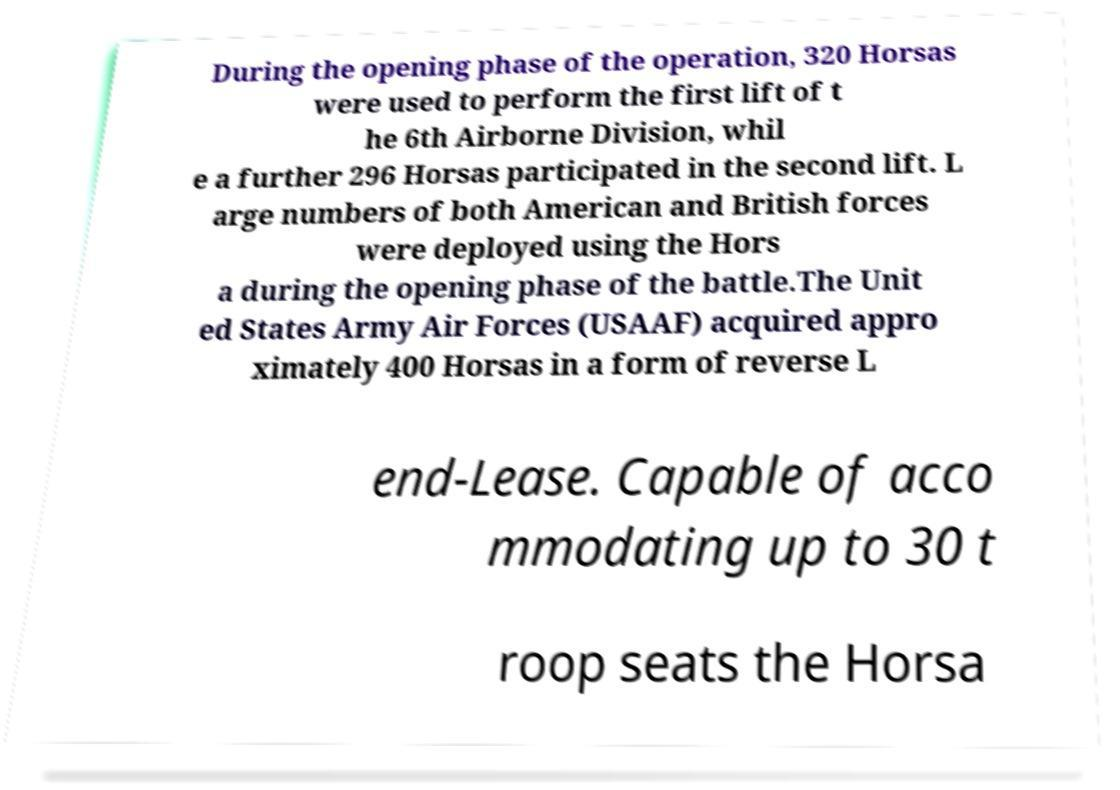Can you accurately transcribe the text from the provided image for me? During the opening phase of the operation, 320 Horsas were used to perform the first lift of t he 6th Airborne Division, whil e a further 296 Horsas participated in the second lift. L arge numbers of both American and British forces were deployed using the Hors a during the opening phase of the battle.The Unit ed States Army Air Forces (USAAF) acquired appro ximately 400 Horsas in a form of reverse L end-Lease. Capable of acco mmodating up to 30 t roop seats the Horsa 